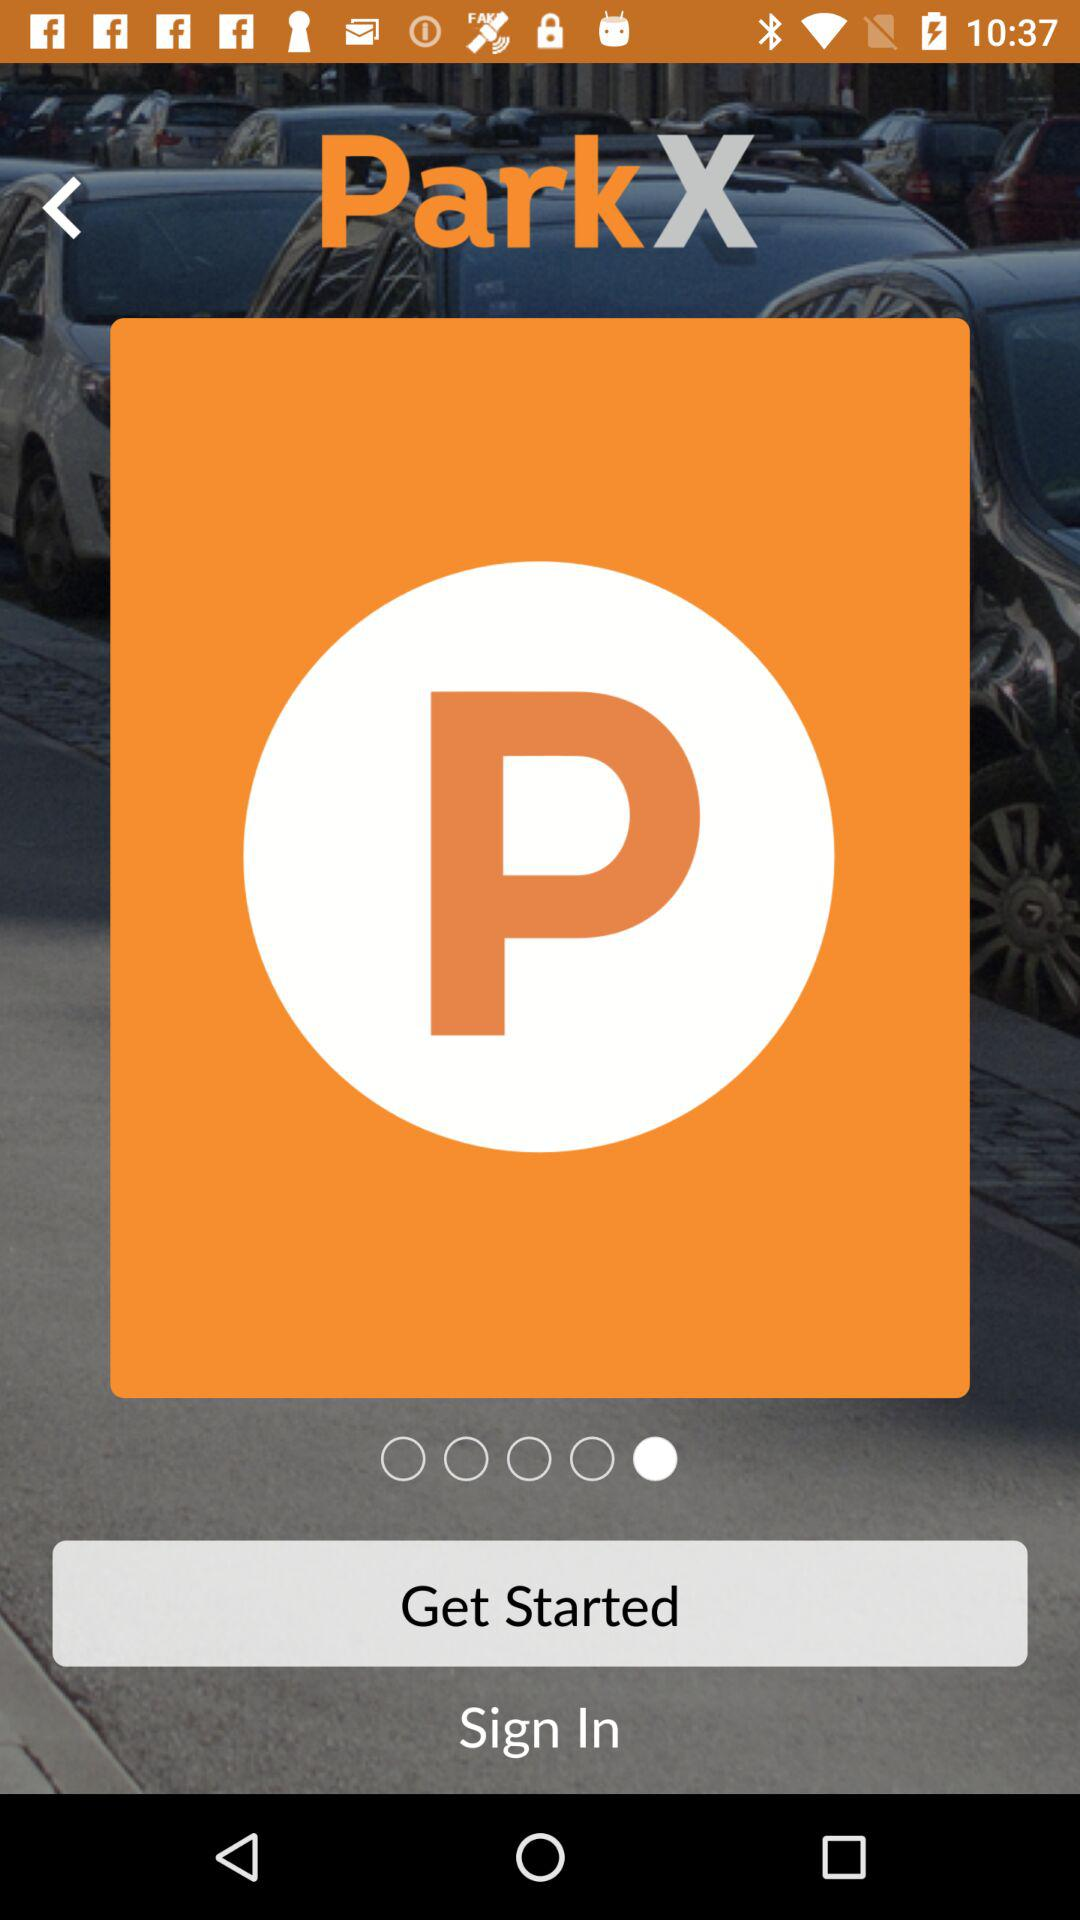How long does it take to sign in?
When the provided information is insufficient, respond with <no answer>. <no answer> 